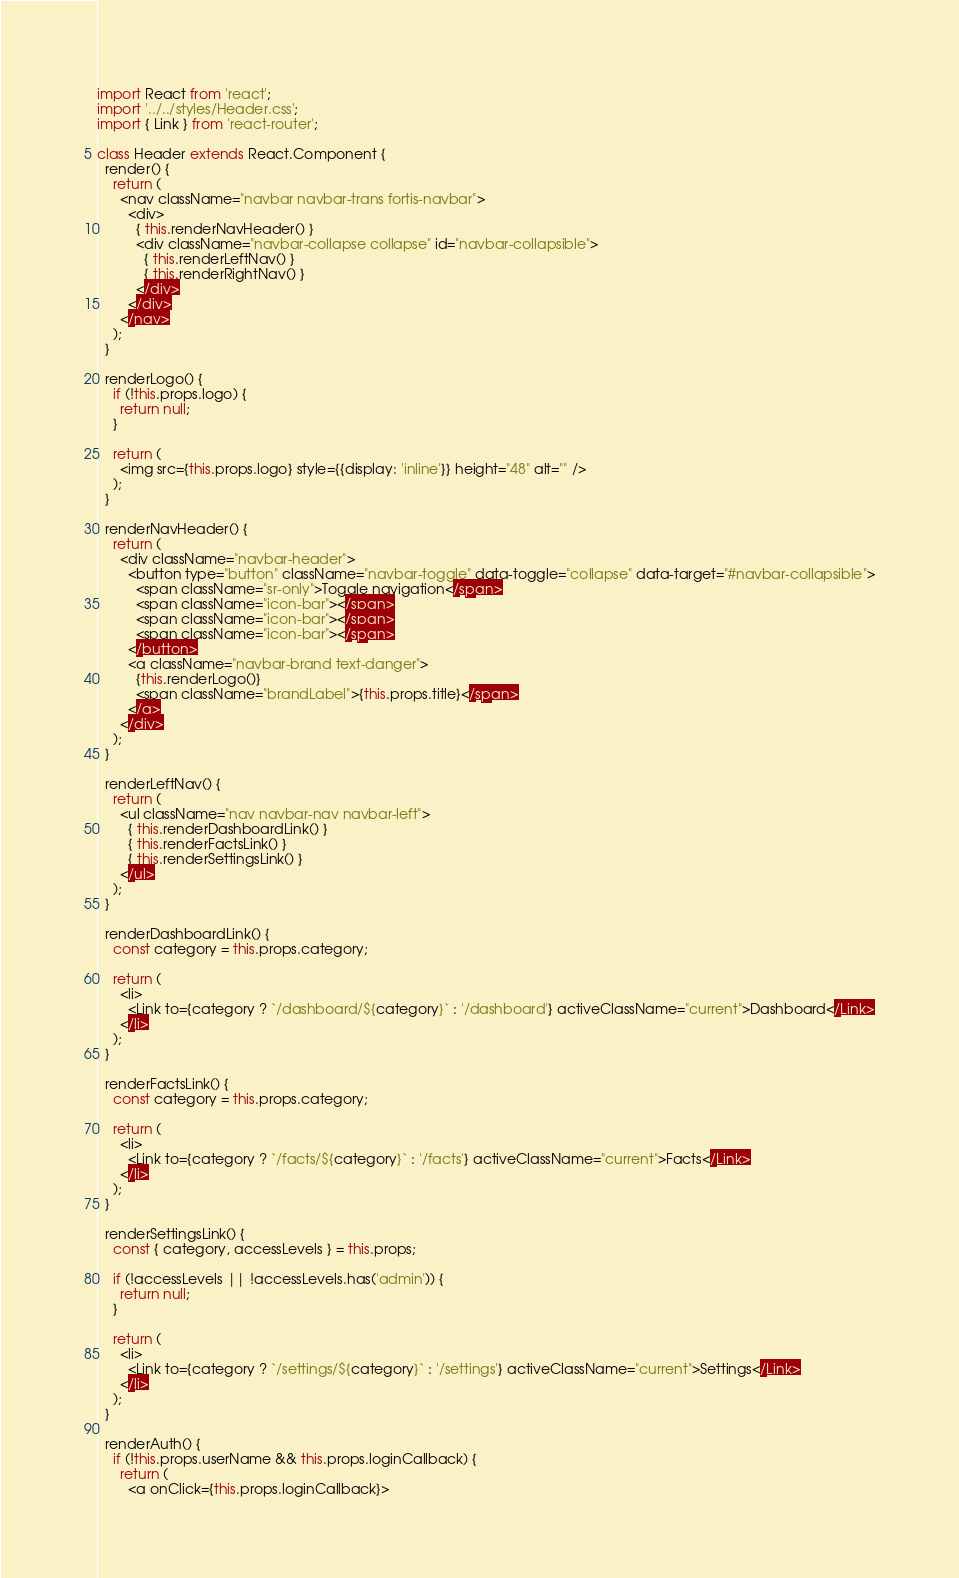Convert code to text. <code><loc_0><loc_0><loc_500><loc_500><_JavaScript_>import React from 'react';
import '../../styles/Header.css';
import { Link } from 'react-router';

class Header extends React.Component {
  render() {
    return (
      <nav className="navbar navbar-trans fortis-navbar">
        <div>
          { this.renderNavHeader() }
          <div className="navbar-collapse collapse" id="navbar-collapsible">
            { this.renderLeftNav() }
            { this.renderRightNav() }
          </div>
        </div>
      </nav>
    );
  }

  renderLogo() {
    if (!this.props.logo) {
      return null;
    }

    return (
      <img src={this.props.logo} style={{display: 'inline'}} height="48" alt="" />
    );
  }

  renderNavHeader() {
    return (
      <div className="navbar-header">
        <button type="button" className="navbar-toggle" data-toggle="collapse" data-target="#navbar-collapsible">
          <span className="sr-only">Toggle navigation</span>
          <span className="icon-bar"></span>
          <span className="icon-bar"></span>
          <span className="icon-bar"></span>
        </button>
        <a className="navbar-brand text-danger">
          {this.renderLogo()}
          <span className="brandLabel">{this.props.title}</span>
        </a>
      </div>
    );
  }

  renderLeftNav() {
    return (
      <ul className="nav navbar-nav navbar-left">
        { this.renderDashboardLink() }
        { this.renderFactsLink() }
        { this.renderSettingsLink() }
      </ul>
    );
  }

  renderDashboardLink() {
    const category = this.props.category;

    return (
      <li>
        <Link to={category ? `/dashboard/${category}` : '/dashboard'} activeClassName="current">Dashboard</Link>
      </li>
    );
  }

  renderFactsLink() {
    const category = this.props.category;

    return (
      <li>
        <Link to={category ? `/facts/${category}` : '/facts'} activeClassName="current">Facts</Link>
      </li>
    );
  }

  renderSettingsLink() {
    const { category, accessLevels } = this.props;

    if (!accessLevels || !accessLevels.has('admin')) {
      return null;
    }

    return (
      <li>
        <Link to={category ? `/settings/${category}` : '/settings'} activeClassName="current">Settings</Link>
      </li>
    );
  }

  renderAuth() {
    if (!this.props.userName && this.props.loginCallback) {
      return (
        <a onClick={this.props.loginCallback}></code> 